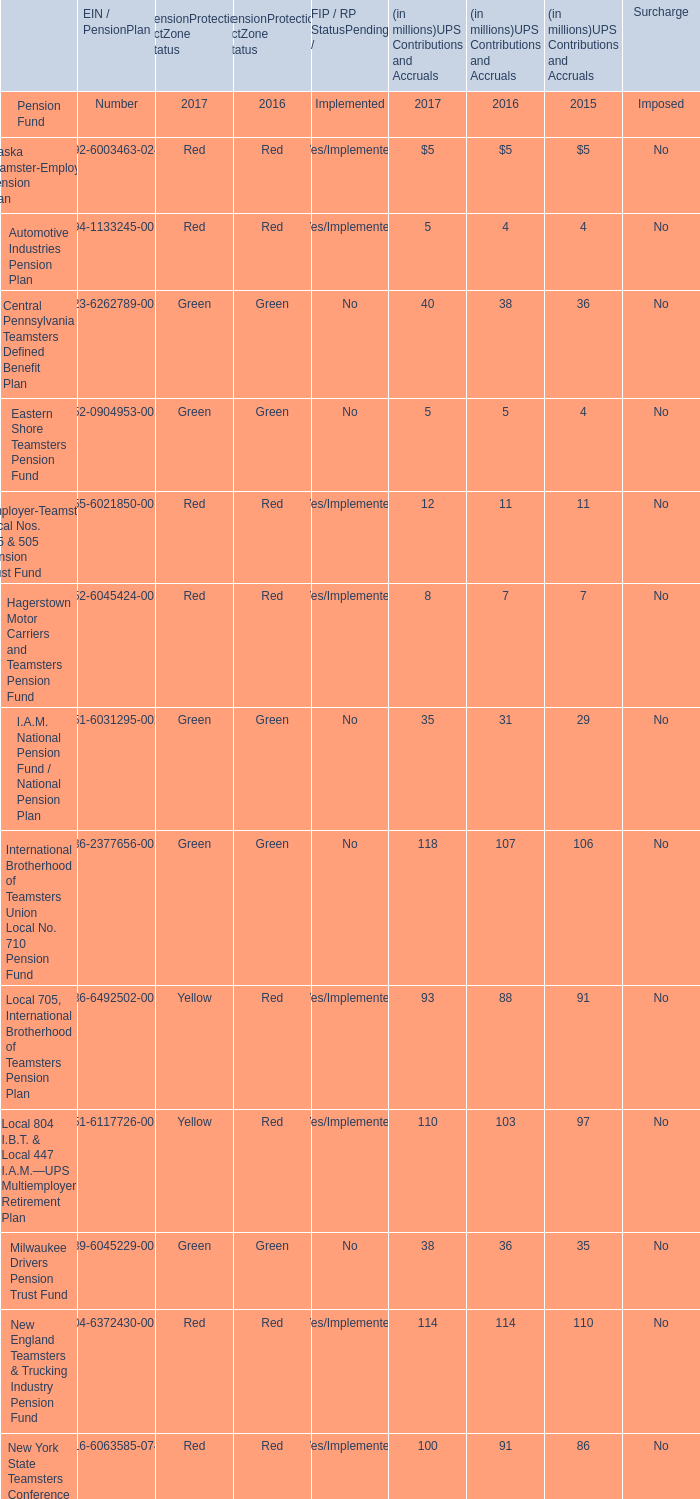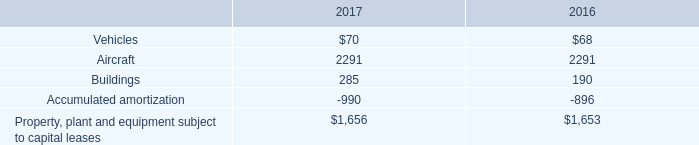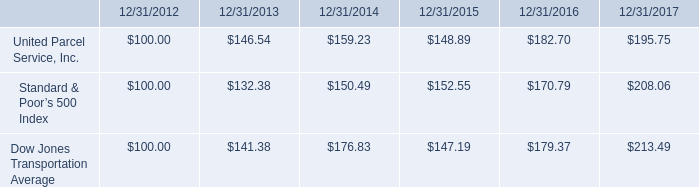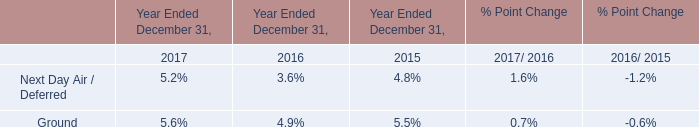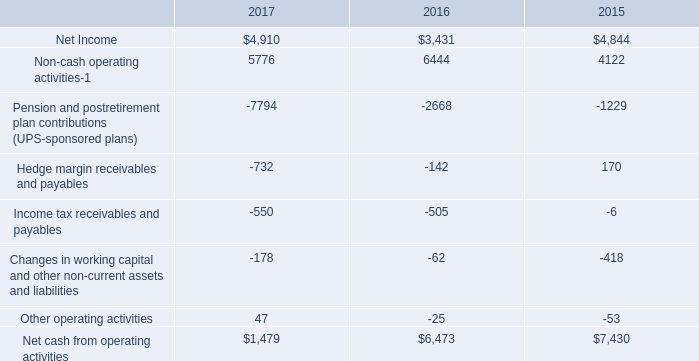what was the percentage change in pension and postretirement plan contributions ( ups-sponsored plans ) from 2015 to 2016? 
Computations: ((2668 - 1229) / 1229)
Answer: 1.17087. 